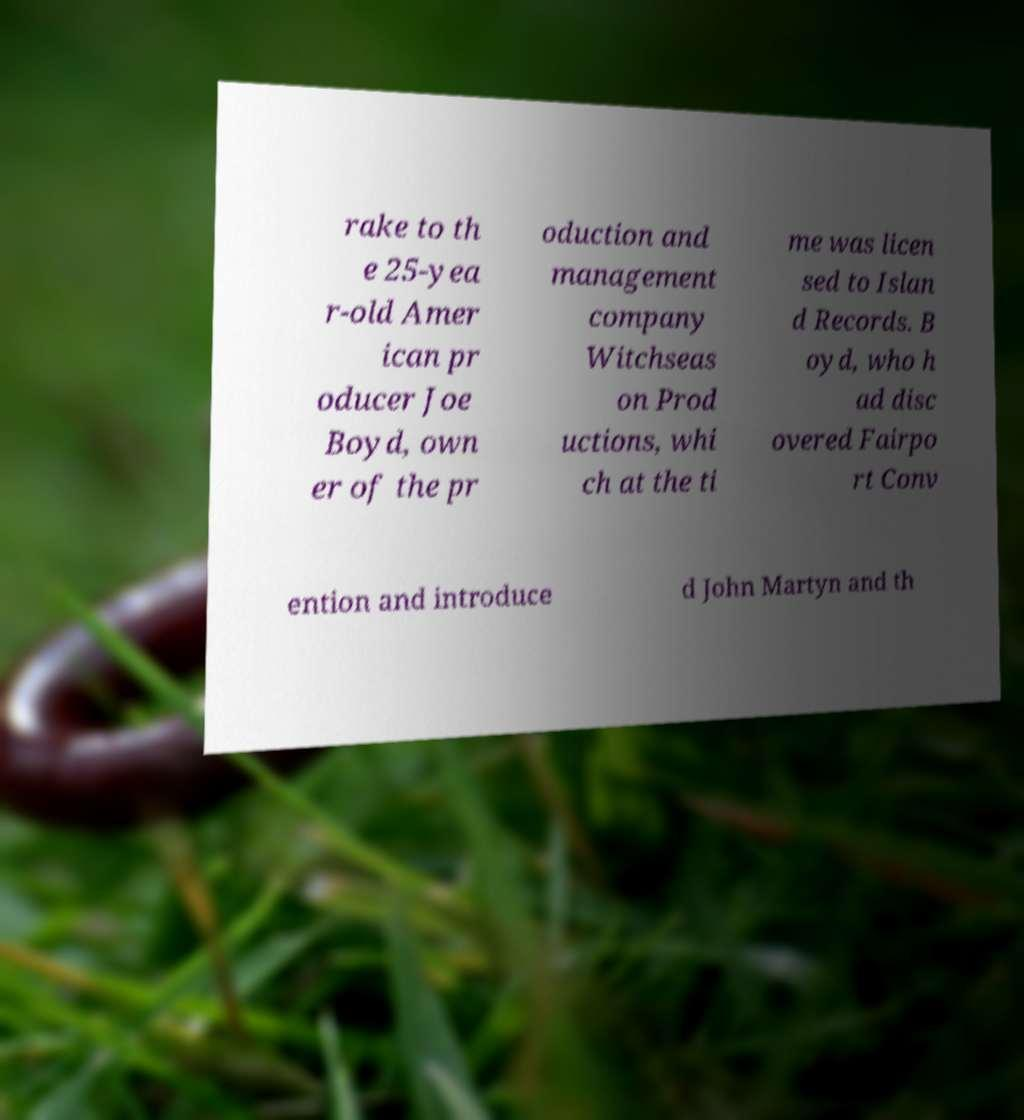Could you assist in decoding the text presented in this image and type it out clearly? rake to th e 25-yea r-old Amer ican pr oducer Joe Boyd, own er of the pr oduction and management company Witchseas on Prod uctions, whi ch at the ti me was licen sed to Islan d Records. B oyd, who h ad disc overed Fairpo rt Conv ention and introduce d John Martyn and th 